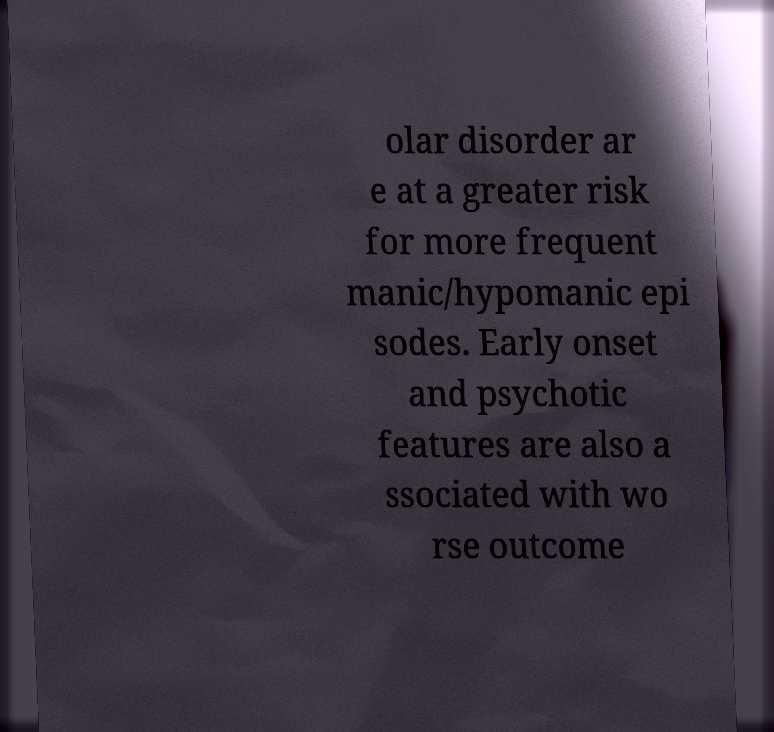Can you accurately transcribe the text from the provided image for me? olar disorder ar e at a greater risk for more frequent manic/hypomanic epi sodes. Early onset and psychotic features are also a ssociated with wo rse outcome 